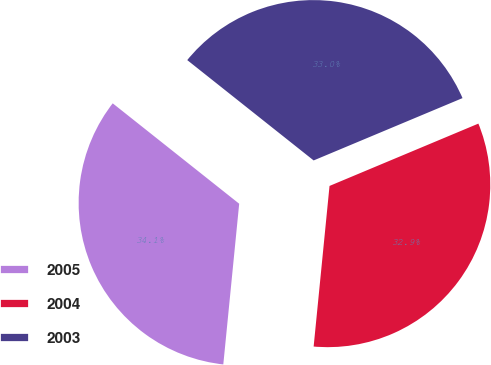Convert chart. <chart><loc_0><loc_0><loc_500><loc_500><pie_chart><fcel>2005<fcel>2004<fcel>2003<nl><fcel>34.11%<fcel>32.88%<fcel>33.01%<nl></chart> 